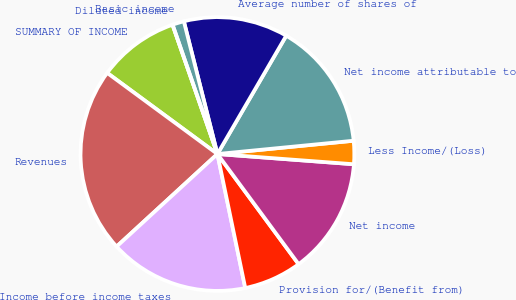Convert chart to OTSL. <chart><loc_0><loc_0><loc_500><loc_500><pie_chart><fcel>SUMMARY OF INCOME<fcel>Revenues<fcel>Income before income taxes<fcel>Provision for/(Benefit from)<fcel>Net income<fcel>Less Income/(Loss)<fcel>Net income attributable to<fcel>Average number of shares of<fcel>Basic income<fcel>Diluted income<nl><fcel>9.59%<fcel>21.92%<fcel>16.44%<fcel>6.85%<fcel>13.7%<fcel>2.74%<fcel>15.07%<fcel>12.33%<fcel>1.37%<fcel>0.0%<nl></chart> 